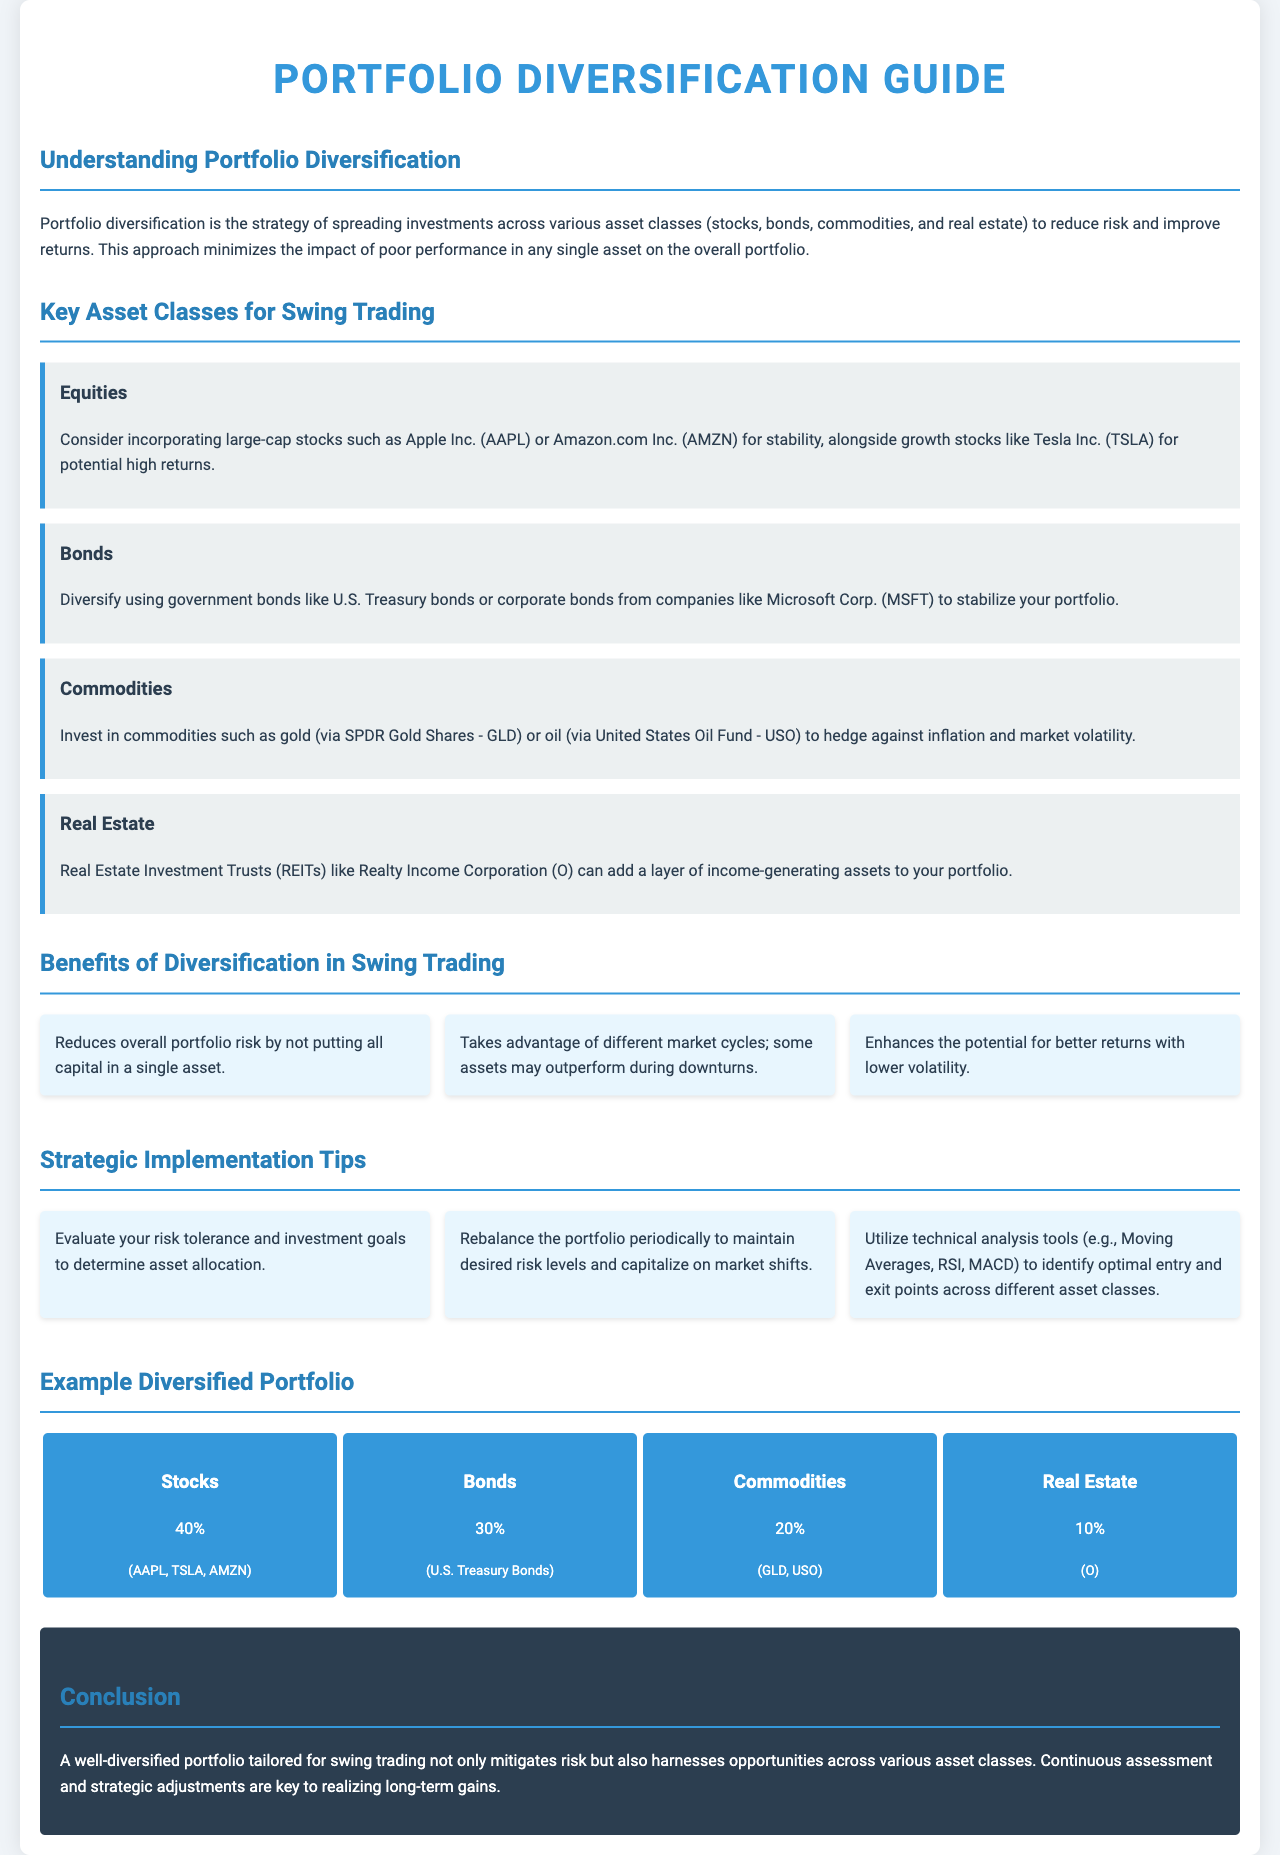What is the main strategy of portfolio diversification? The strategy is to spread investments across various asset classes to reduce risk and improve returns.
Answer: Spread investments across various asset classes Which asset class is suggested for stability? The text mentions incorporating large-cap stocks for stability, specifically naming companies like Apple Inc. and Amazon.com Inc.
Answer: Large-cap stocks What percentage of the example diversified portfolio is allocated to stocks? The document states that 40% of the example portfolio is allocated to stocks.
Answer: 40% Name one technical analysis tool mentioned in the document. The document lists technical analysis tools, specifically mentioning Moving Averages.
Answer: Moving Averages How many benefits of diversification are listed? There are three benefits detailed in the section on benefits of diversification in swing trading.
Answer: Three What is the recommendation for portfolio rebalancing? The text advises to rebalance the portfolio periodically to maintain desired risk levels.
Answer: Periodically Which asset class represents the smallest percentage in the example portfolio? Real estate is allocated 10%, making it the smallest percentage in the example portfolio.
Answer: Real Estate What is the main conclusion regarding a well-diversified portfolio? The conclusion emphasizes that a well-diversified portfolio mitigates risk while harnessing opportunities across various asset classes.
Answer: Mitigates risk 